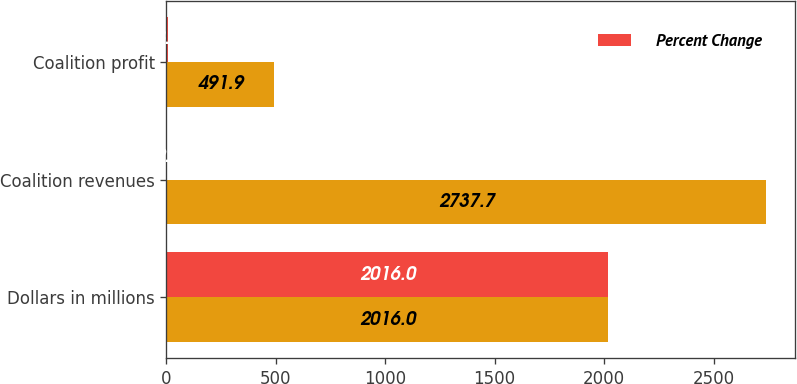<chart> <loc_0><loc_0><loc_500><loc_500><stacked_bar_chart><ecel><fcel>Dollars in millions<fcel>Coalition revenues<fcel>Coalition profit<nl><fcel>nan<fcel>2016<fcel>2737.7<fcel>491.9<nl><fcel>Percent Change<fcel>2016<fcel>2<fcel>8.1<nl></chart> 